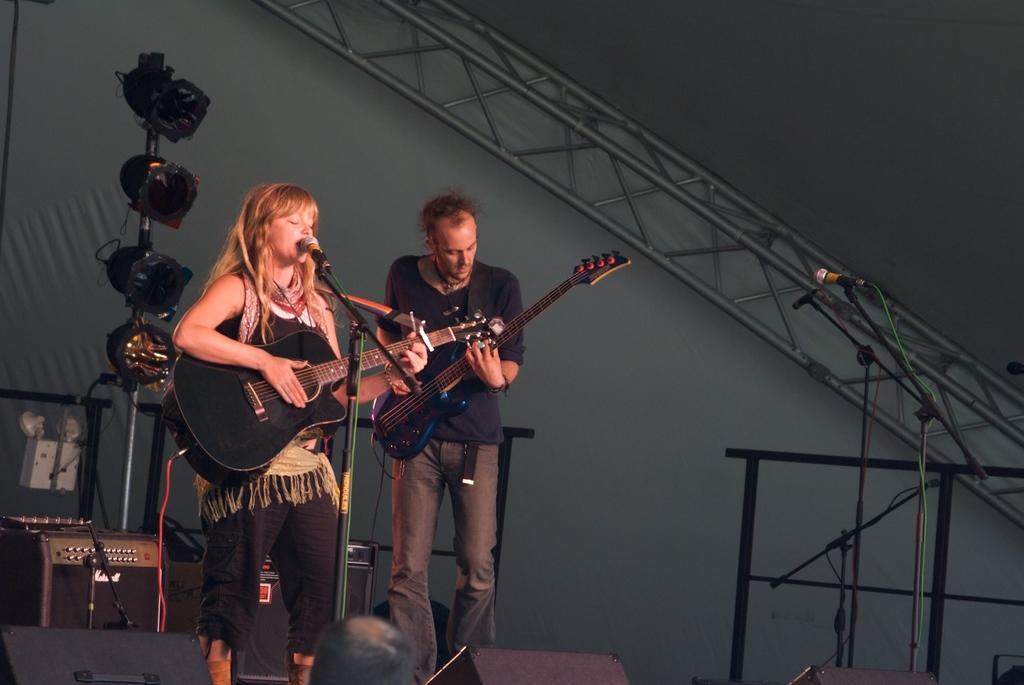How would you summarize this image in a sentence or two? In this image i can see a woman and a man holding guitars and i can see microphone in front of a woman. In the background i can see a wall, metal rods and few lights. 